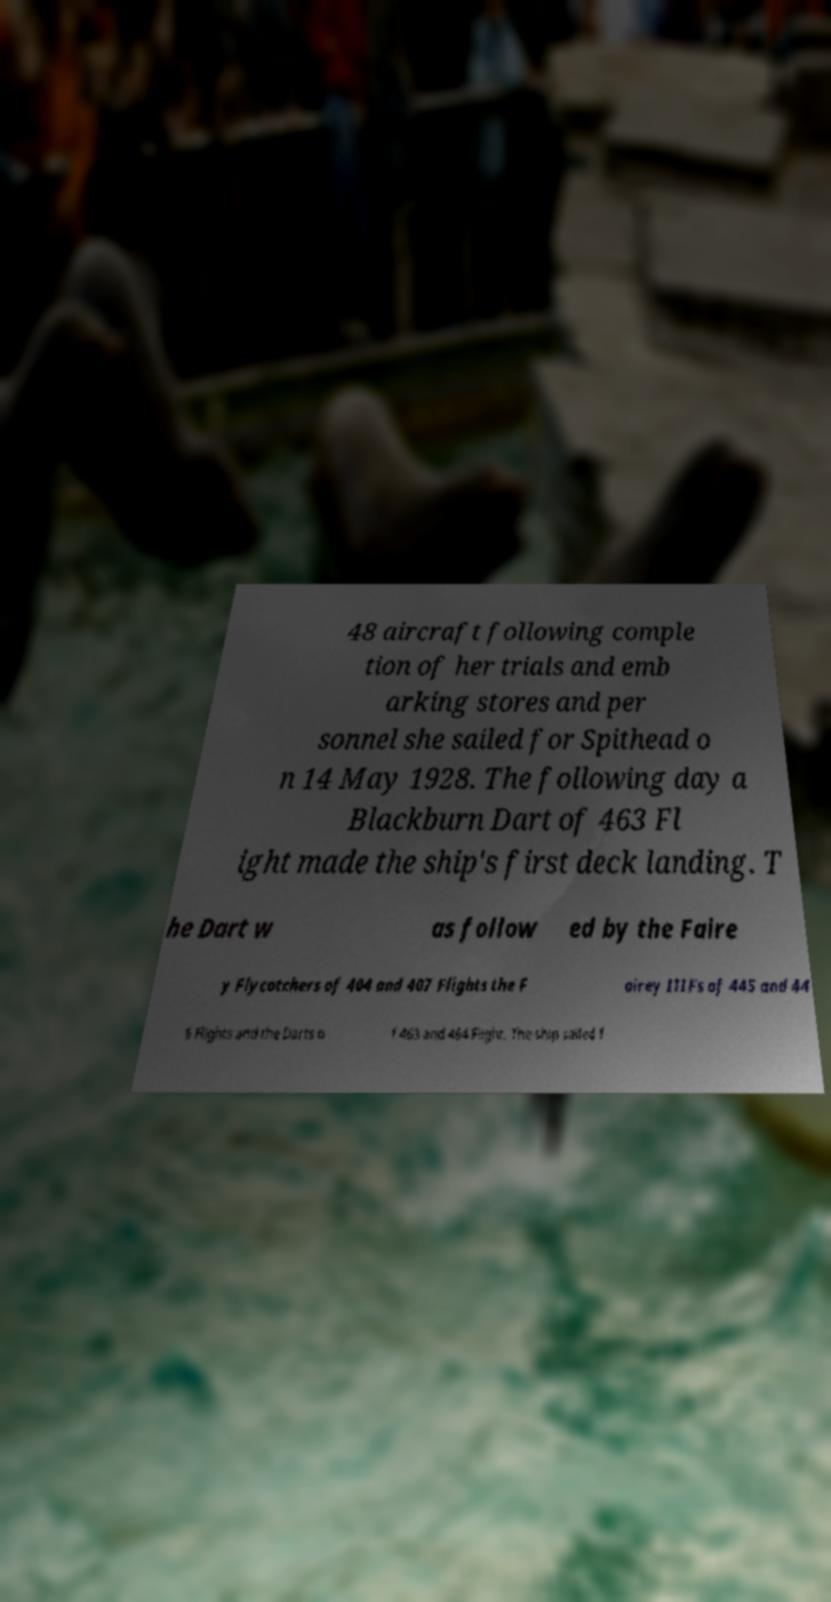Could you extract and type out the text from this image? 48 aircraft following comple tion of her trials and emb arking stores and per sonnel she sailed for Spithead o n 14 May 1928. The following day a Blackburn Dart of 463 Fl ight made the ship's first deck landing. T he Dart w as follow ed by the Faire y Flycatchers of 404 and 407 Flights the F airey IIIFs of 445 and 44 6 Flights and the Darts o f 463 and 464 Flight. The ship sailed f 